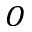<formula> <loc_0><loc_0><loc_500><loc_500>O</formula> 